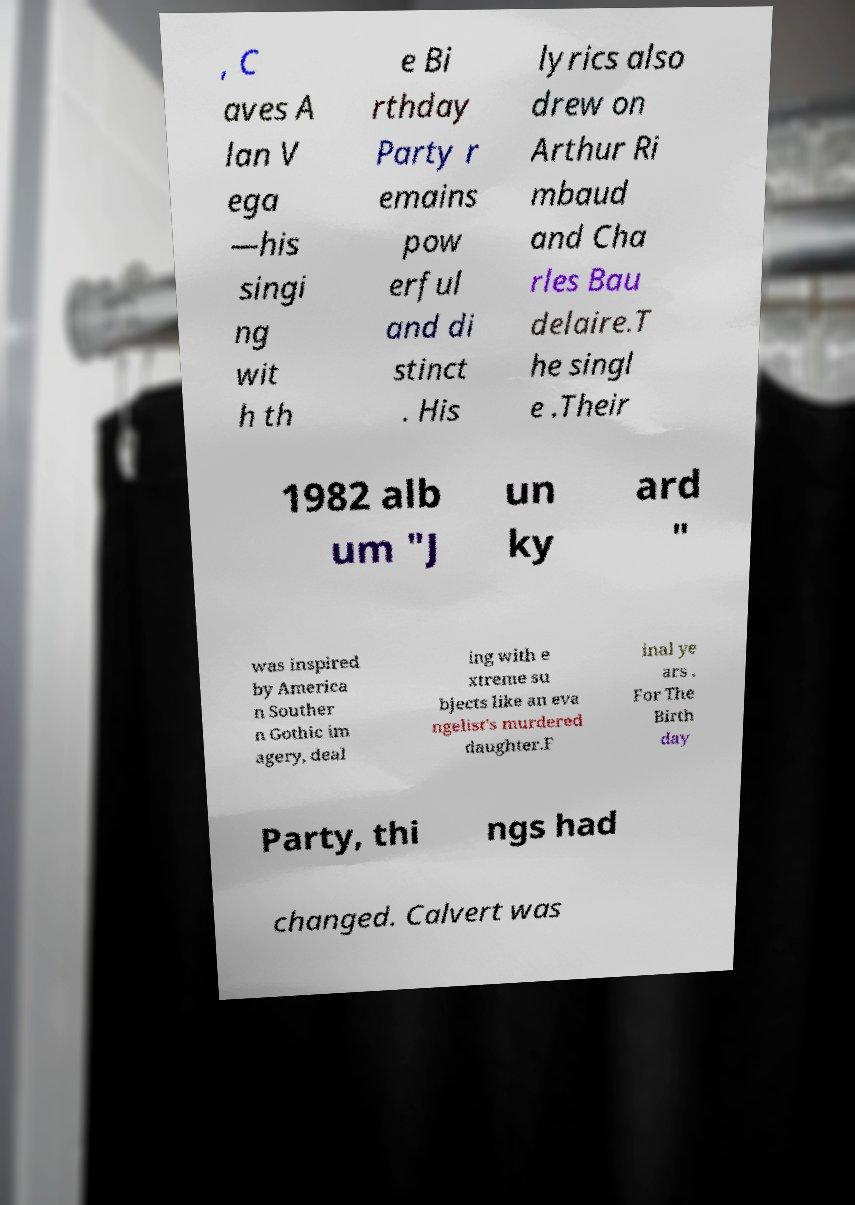For documentation purposes, I need the text within this image transcribed. Could you provide that? , C aves A lan V ega —his singi ng wit h th e Bi rthday Party r emains pow erful and di stinct . His lyrics also drew on Arthur Ri mbaud and Cha rles Bau delaire.T he singl e .Their 1982 alb um "J un ky ard " was inspired by America n Souther n Gothic im agery, deal ing with e xtreme su bjects like an eva ngelist's murdered daughter.F inal ye ars . For The Birth day Party, thi ngs had changed. Calvert was 